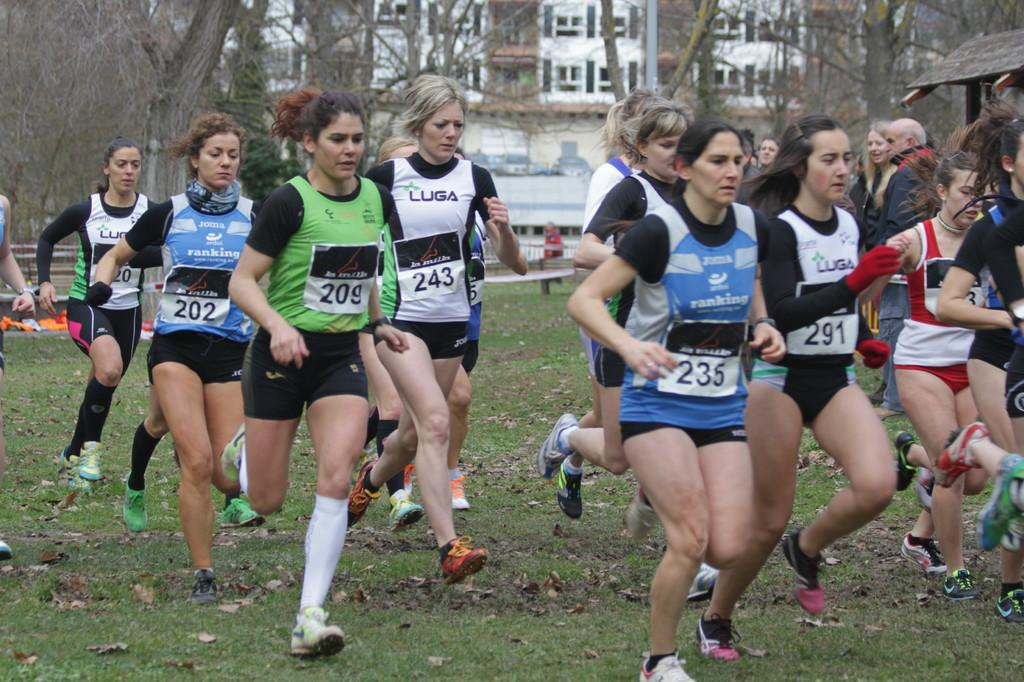<image>
Offer a succinct explanation of the picture presented. Runner 291 and 243 have been sponsored by LUGA. 